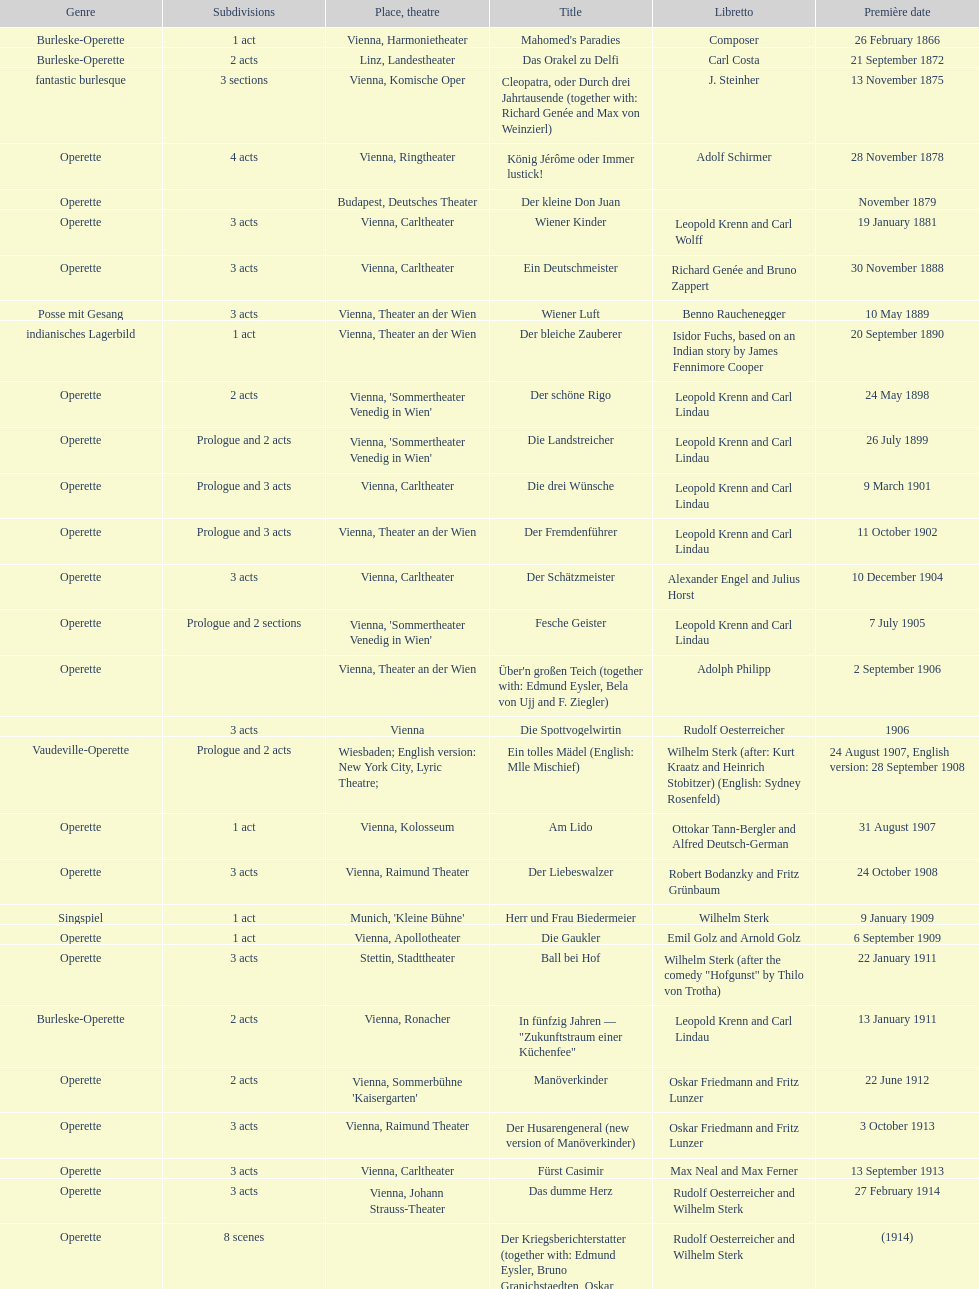Which year did he release his last operetta? 1930. 